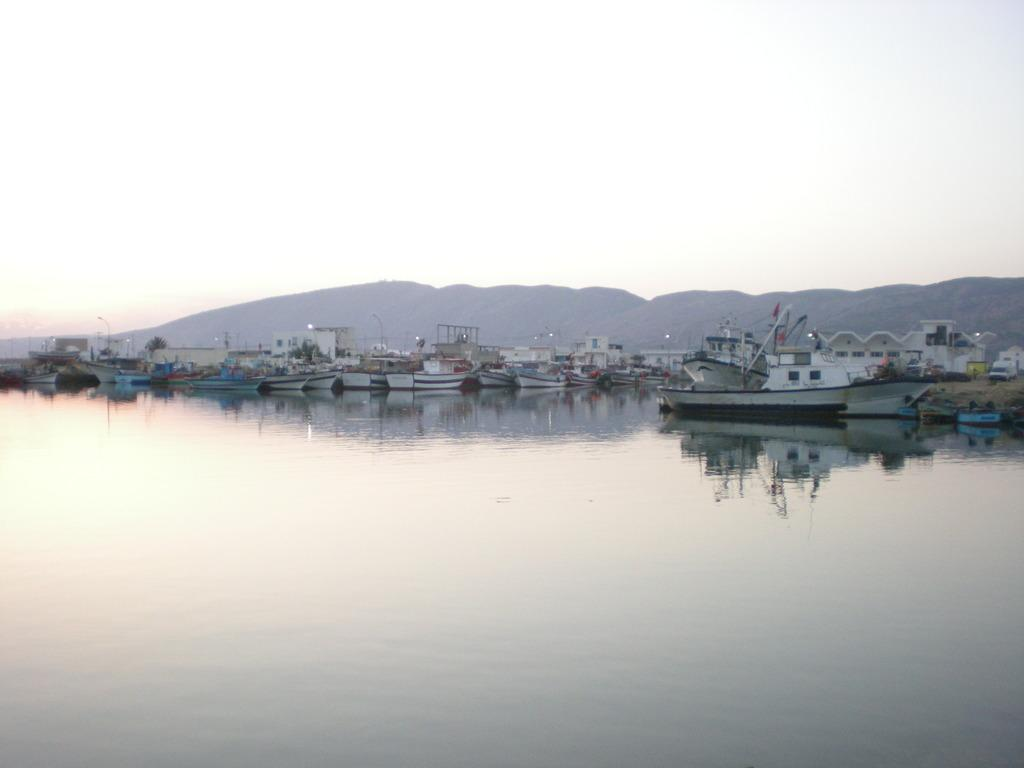What is the primary element visible in the picture? There is water in the picture. What can be seen floating on the water? There are boats in the picture. What type of structures are visible in the background? There are buildings in the background of the picture. What natural feature is present in the background? There are mountains in the background of the picture. What type of suit is the porter wearing while carrying the pot in the image? There is no porter, suit, suit, or pot present in the image. 